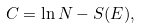<formula> <loc_0><loc_0><loc_500><loc_500>C = \ln N - S ( E ) ,</formula> 